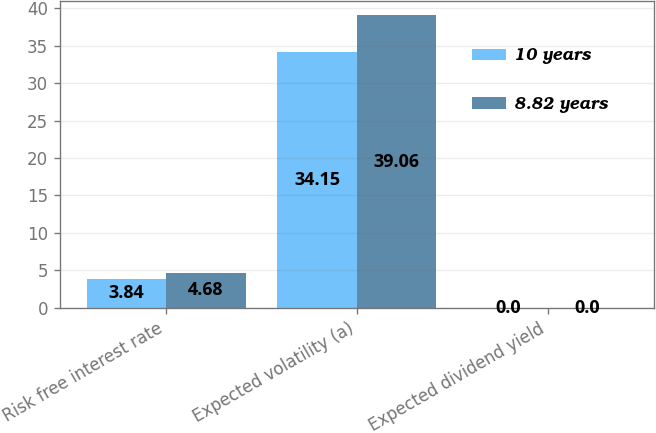Convert chart. <chart><loc_0><loc_0><loc_500><loc_500><stacked_bar_chart><ecel><fcel>Risk free interest rate<fcel>Expected volatility (a)<fcel>Expected dividend yield<nl><fcel>10 years<fcel>3.84<fcel>34.15<fcel>0<nl><fcel>8.82 years<fcel>4.68<fcel>39.06<fcel>0<nl></chart> 